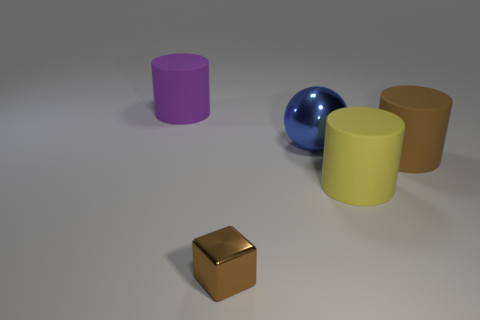Add 1 large brown metallic spheres. How many objects exist? 6 Subtract all purple cylinders. Subtract all cyan blocks. How many cylinders are left? 2 Subtract all cubes. How many objects are left? 4 Add 2 small purple shiny objects. How many small purple shiny objects exist? 2 Subtract 0 green cylinders. How many objects are left? 5 Subtract all gray matte blocks. Subtract all small blocks. How many objects are left? 4 Add 3 tiny brown cubes. How many tiny brown cubes are left? 4 